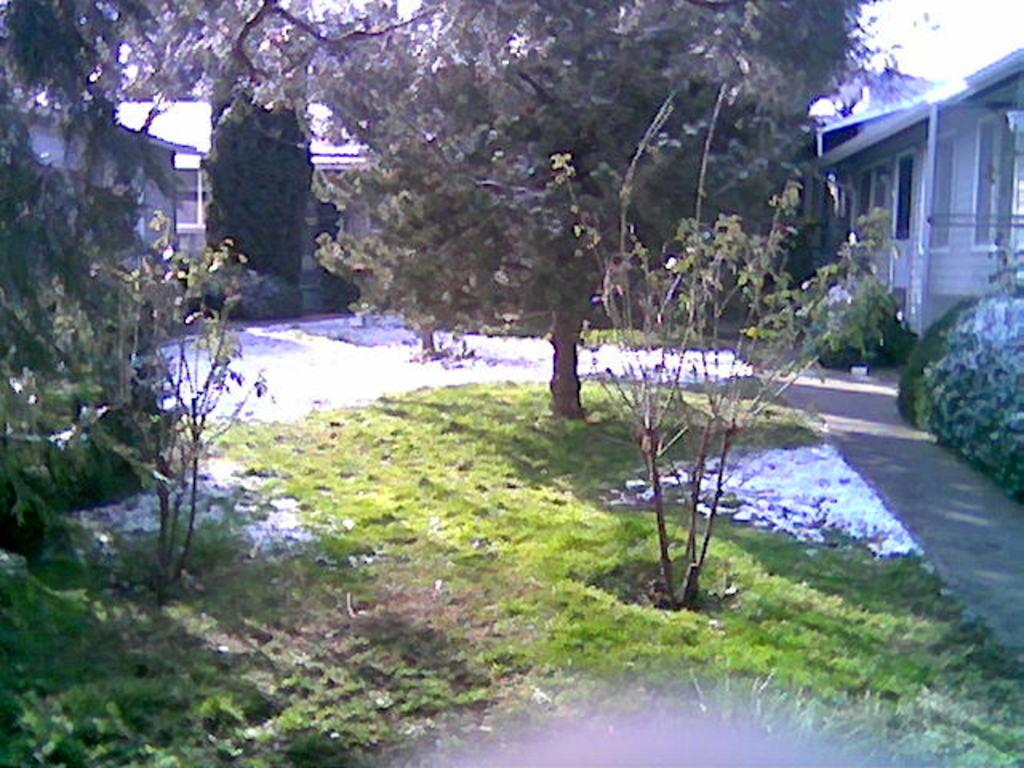What type of ground is visible in the image? The ground in the image is covered in greenery. What type of vegetation can be seen in the image? There are trees in the image. What structures are located near the greenery? There are houses on either side of the greenery. What type of songs can be heard coming from the mine in the image? There is no mine present in the image, so it's not possible to determine what, if any, songs might be heard. 